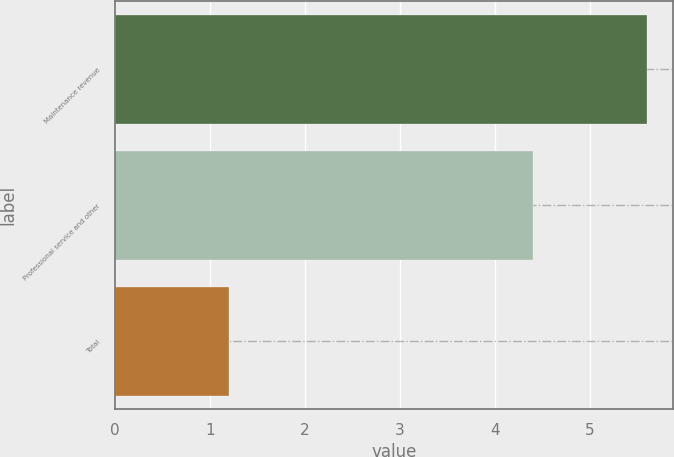Convert chart. <chart><loc_0><loc_0><loc_500><loc_500><bar_chart><fcel>Maintenance revenue<fcel>Professional service and other<fcel>Total<nl><fcel>5.6<fcel>4.4<fcel>1.2<nl></chart> 